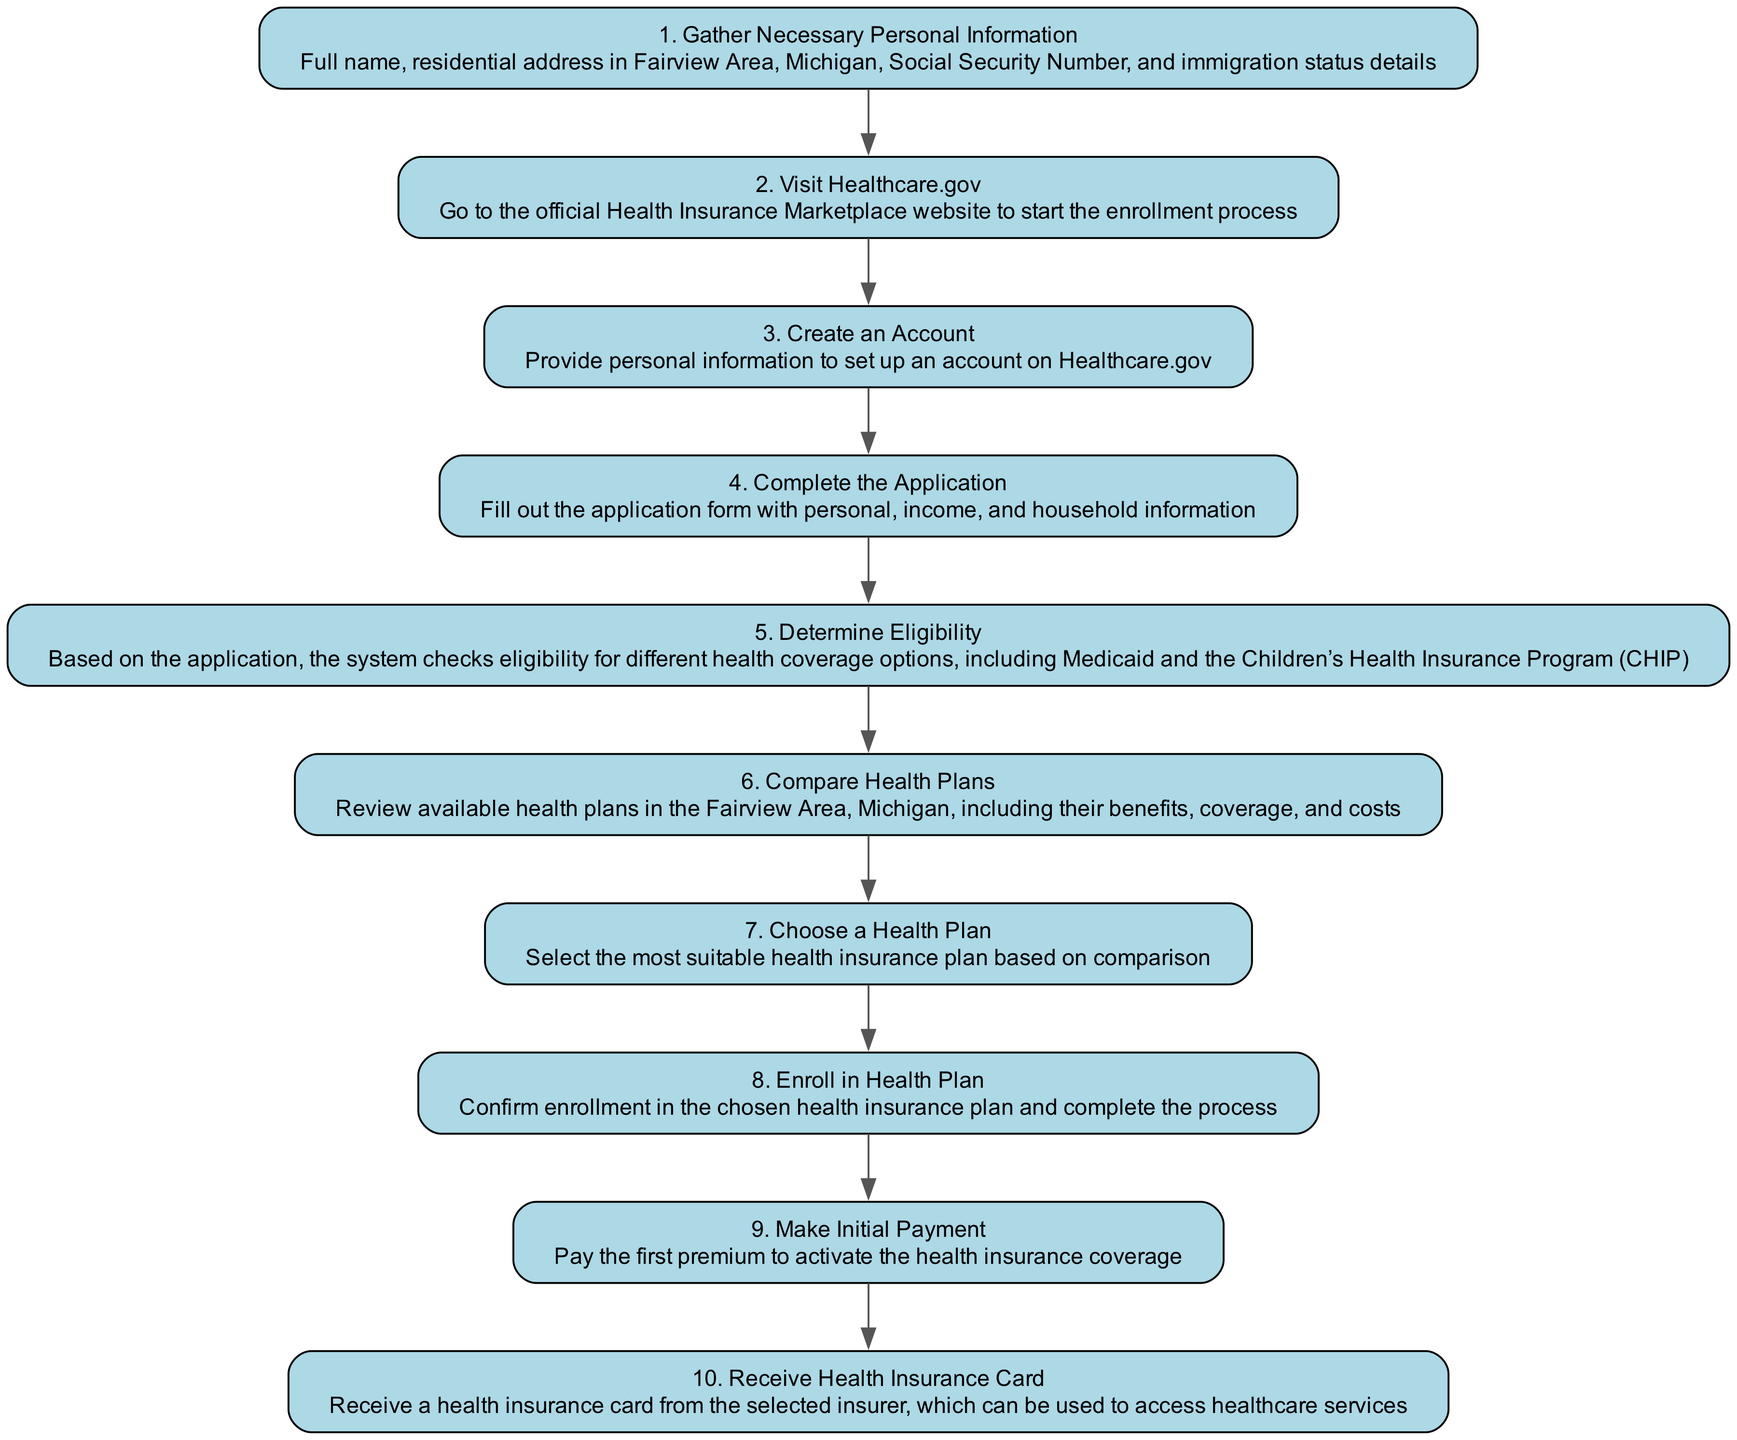What is the first action in the enrollment process? The first action in the flowchart is "Gather Necessary Personal Information," indicating that this is the initial step that needs to be completed before proceeding further.
Answer: Gather Necessary Personal Information How many steps are there in the enrollment process? By counting the numbered nodes from 1 to 10 in the diagram, it is clear that there are a total of 10 steps in the enrollment process.
Answer: 10 What comes immediately after "Visit Healthcare.gov"? The diagram shows that "Create an Account" follows "Visit Healthcare.gov," indicating the direct progression to the next step after visiting the website.
Answer: Create an Account What is the last action in the process? The final action in the flowchart is "Receive Health Insurance Card," which signifies the completion of the enrollment process into healthcare.
Answer: Receive Health Insurance Card How many actions involve making a choice? There are two actions that involve making a choice: "Choose a Health Plan" and "Enroll in Health Plan," indicating the critical decision points in the process.
Answer: 2 What is the relationship between "Determine Eligibility" and "Compare Health Plans"? The relationship is sequential; "Determine Eligibility" comes before "Compare Health Plans," indicating that eligibility must be established prior to reviewing health plans available for selection.
Answer: Sequential Which step requires you to fill out a form? The step that requires filling out a form is "Complete the Application," which specifically mentions filling out the application form with necessary information.
Answer: Complete the Application What payment is needed to activate coverage? To activate health insurance coverage, the action "Make Initial Payment" is required, highlighting the necessity of this payment within the enrollment process.
Answer: Make Initial Payment What is checked during the "Determine Eligibility" step? Eligibility checks involve determining qualification for various health coverage options, such as Medicaid and the Children’s Health Insurance Program (CHIP), indicating the verification process occurring at that stage.
Answer: Health coverage options What action must be taken after selecting a health plan? After choosing a health plan, the next required action is to "Enroll in Health Plan," indicating the transition from selection to formal enrollment.
Answer: Enroll in Health Plan 